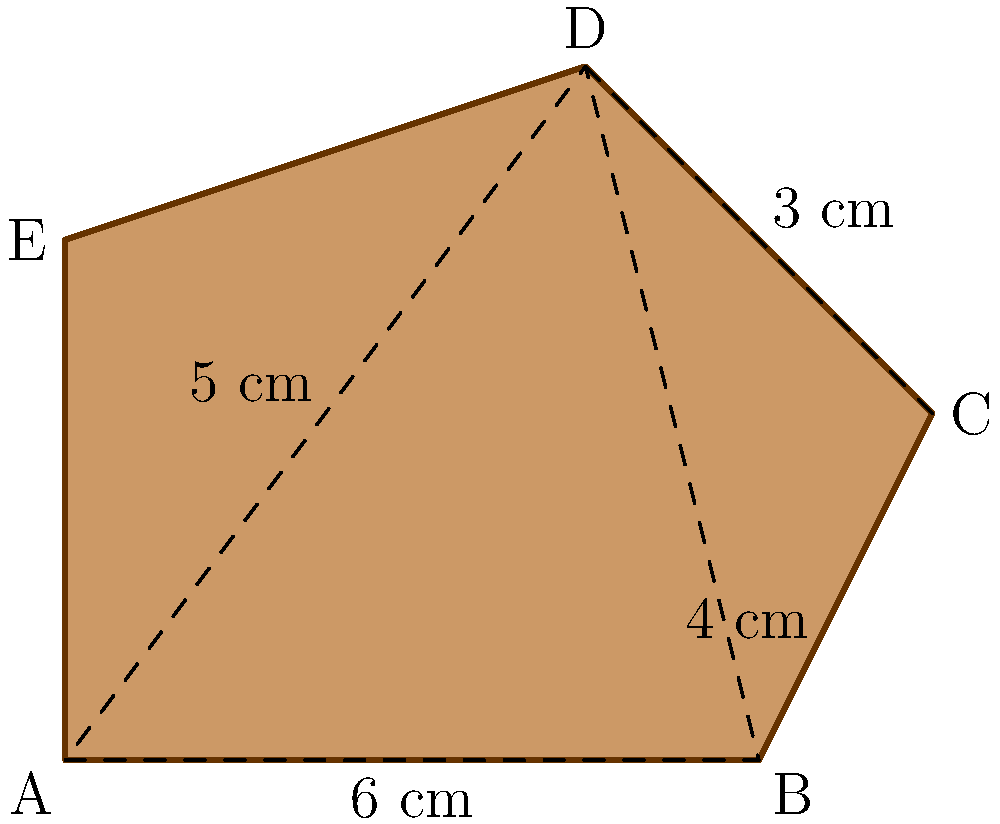In your latest adventure as Nathan Drake, you've discovered an irregularly shaped ancient artifact. To properly document it, you need to calculate its area. The artifact can be divided into a triangle and a trapezoid. Given that AB = 6 cm, BC = 4 cm, AD = 5 cm, and DC = 3 cm, what is the total area of the artifact in square centimeters? Let's approach this step-by-step, just like Nathan Drake would analyze a puzzle:

1) First, let's calculate the area of the triangle ABD:
   - We know the base (AB) is 6 cm and the height (AD) is 5 cm
   - Area of a triangle = $\frac{1}{2} \times base \times height$
   - Area of triangle ABD = $\frac{1}{2} \times 6 \times 5 = 15$ cm²

2) Now, let's calculate the area of the trapezoid BCDE:
   - We know the parallel sides are BC (4 cm) and DE (which is AB - BC = 6 - 4 = 2 cm)
   - The height of the trapezoid is the same as DC, which is 3 cm
   - Area of a trapezoid = $\frac{1}{2} \times (a + b) \times h$, where a and b are the parallel sides and h is the height
   - Area of trapezoid BCDE = $\frac{1}{2} \times (4 + 2) \times 3 = 9$ cm²

3) The total area of the artifact is the sum of these two areas:
   Total Area = Area of triangle ABD + Area of trapezoid BCDE
               = 15 cm² + 9 cm² = 24 cm²

Thus, the total area of the artifact is 24 square centimeters.
Answer: 24 cm² 